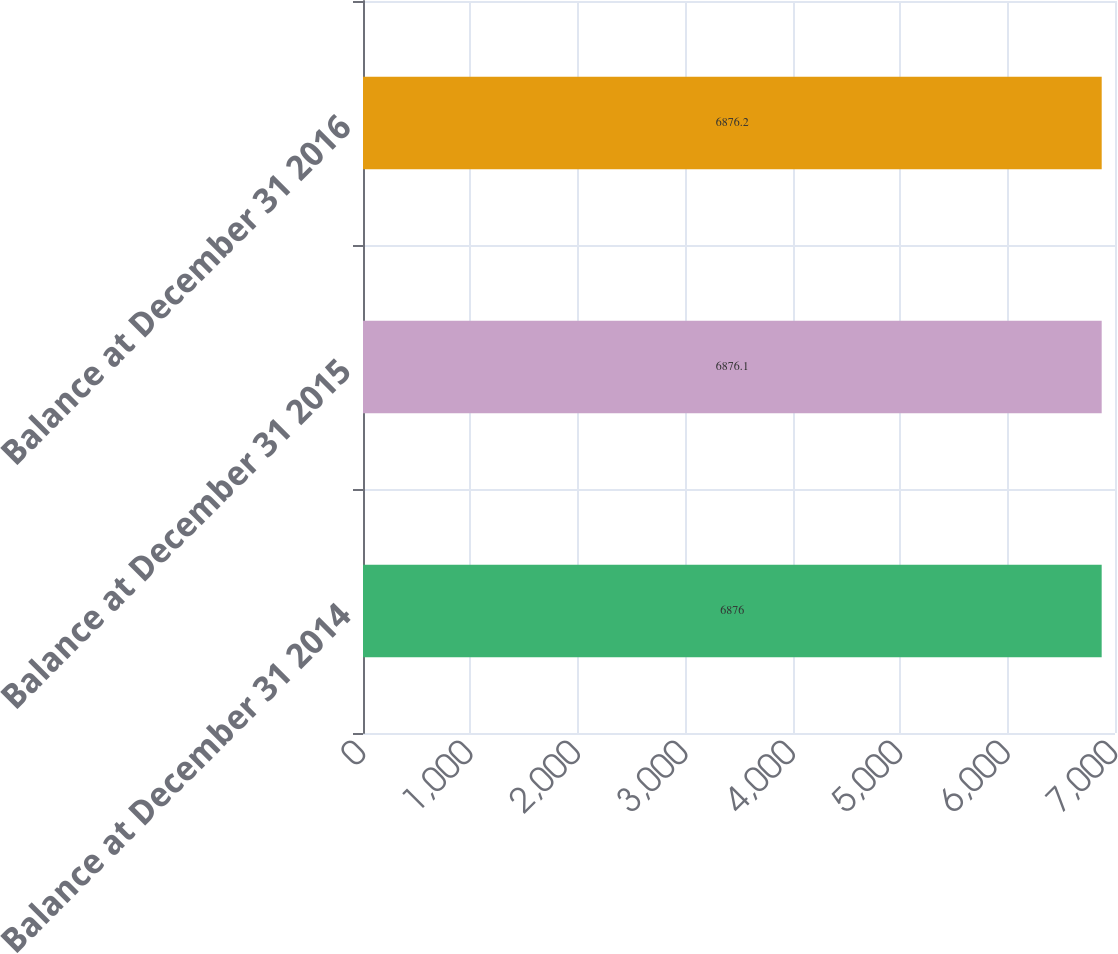Convert chart. <chart><loc_0><loc_0><loc_500><loc_500><bar_chart><fcel>Balance at December 31 2014<fcel>Balance at December 31 2015<fcel>Balance at December 31 2016<nl><fcel>6876<fcel>6876.1<fcel>6876.2<nl></chart> 